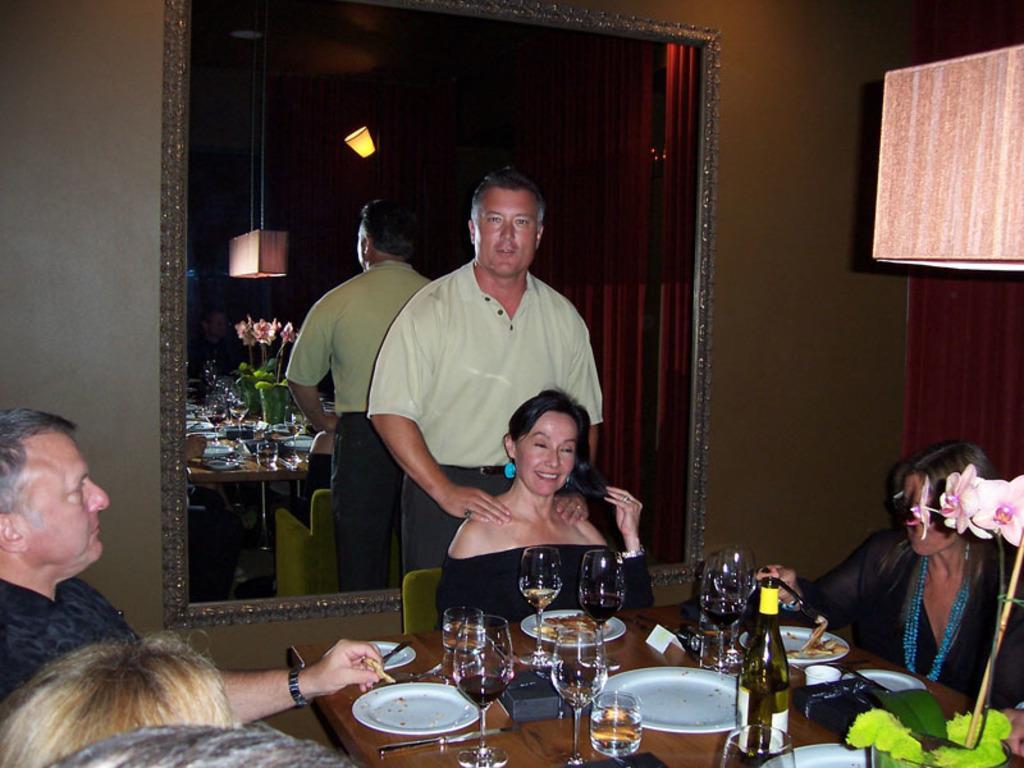Please provide a concise description of this image. This is the picture inside the room. There are group of people in the image. There are glasses, plates,spoons, plant on the table. At the back there is a mirror, at the right there is a light and red curtain. 